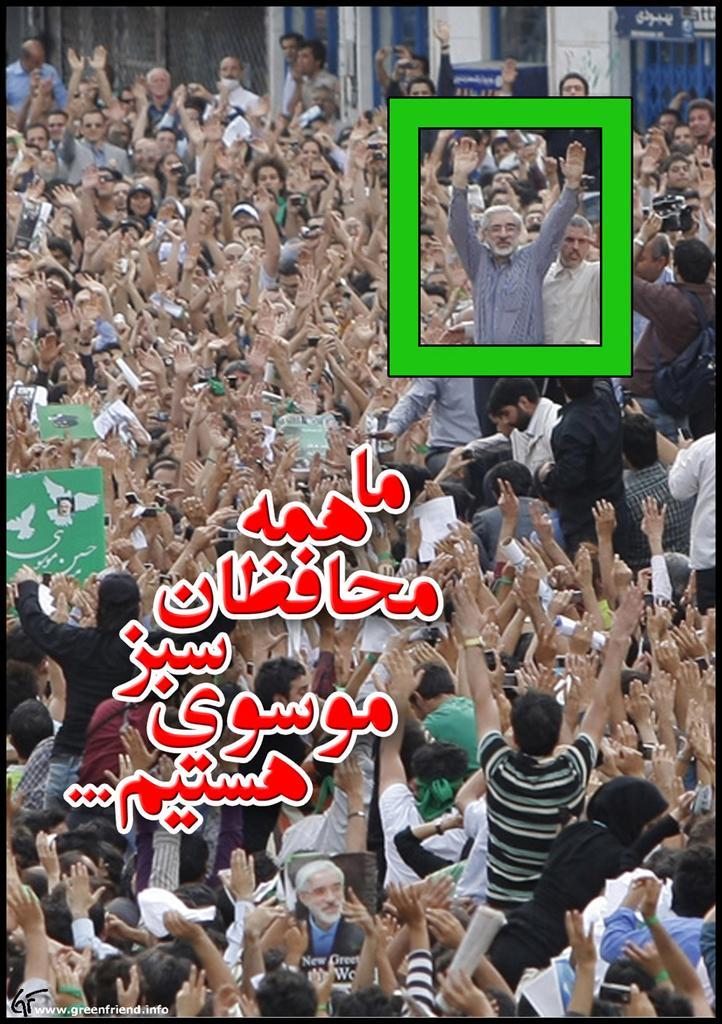How would you summarize this image in a sentence or two? In this image there are group of people standing with hands up behind them there is a building and also there is some text. 